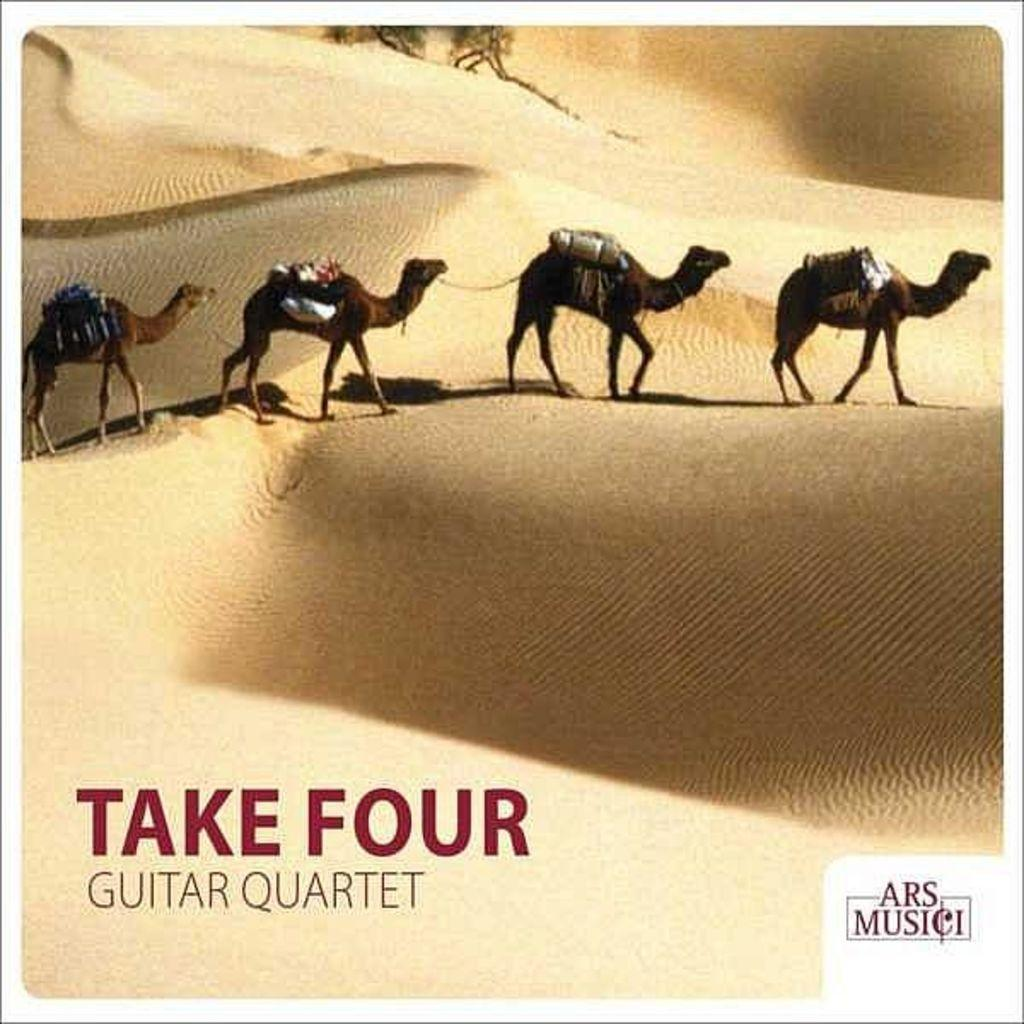How many camels are in the image? There are four camels in the image. What are the camels carrying? The camels are carrying bags. Where are the camels standing? The camels are standing on the desert. Is there any text in the image? Yes, there is a text at the bottom of the image. What type of apples are being sold at the store in the image? There is no store or apples present in the image; it features four camels standing on the desert. 